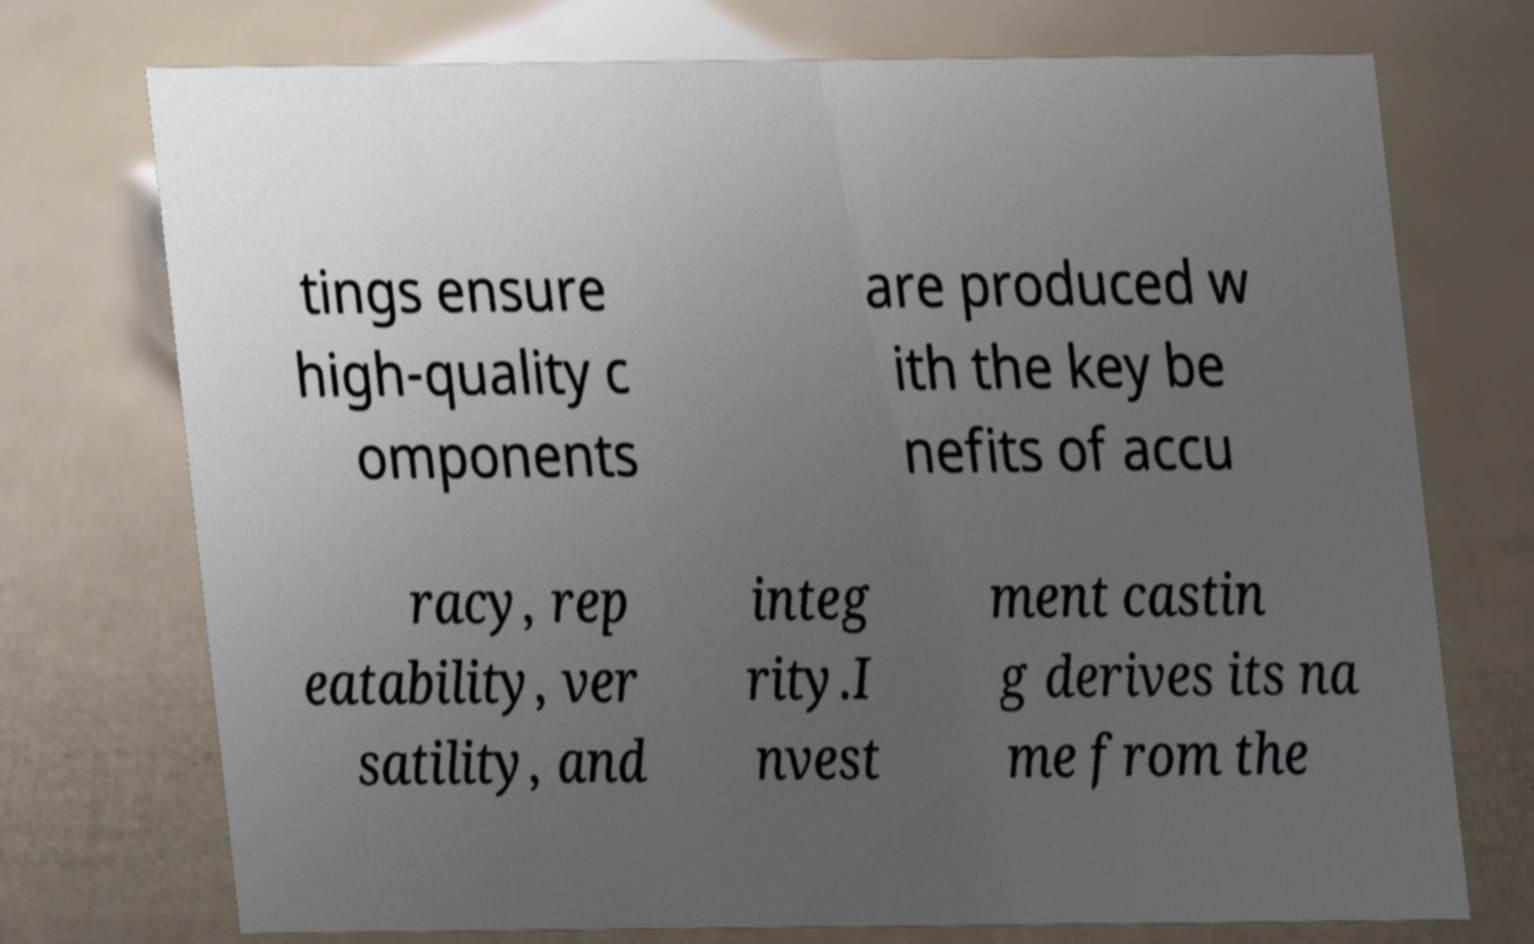Could you extract and type out the text from this image? tings ensure high-quality c omponents are produced w ith the key be nefits of accu racy, rep eatability, ver satility, and integ rity.I nvest ment castin g derives its na me from the 